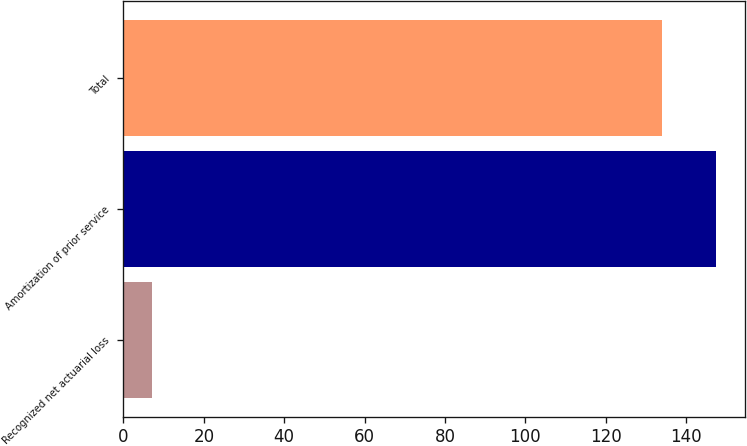Convert chart to OTSL. <chart><loc_0><loc_0><loc_500><loc_500><bar_chart><fcel>Recognized net actuarial loss<fcel>Amortization of prior service<fcel>Total<nl><fcel>7<fcel>147.4<fcel>134<nl></chart> 